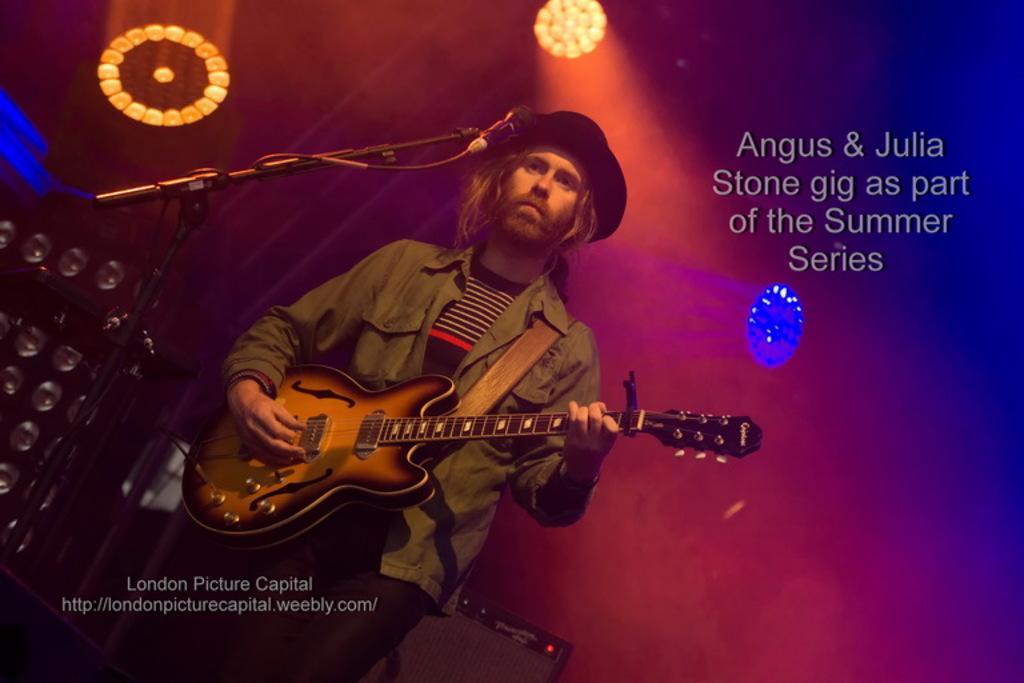Please provide a concise description of this image. n this image i can see a man standing and holding a guitar, he is wearing a black shirt and a green shirt over it and a black pant , at the back ground i can see a banner and some thing written on it, few lights, in front of a man there is a microphone. 